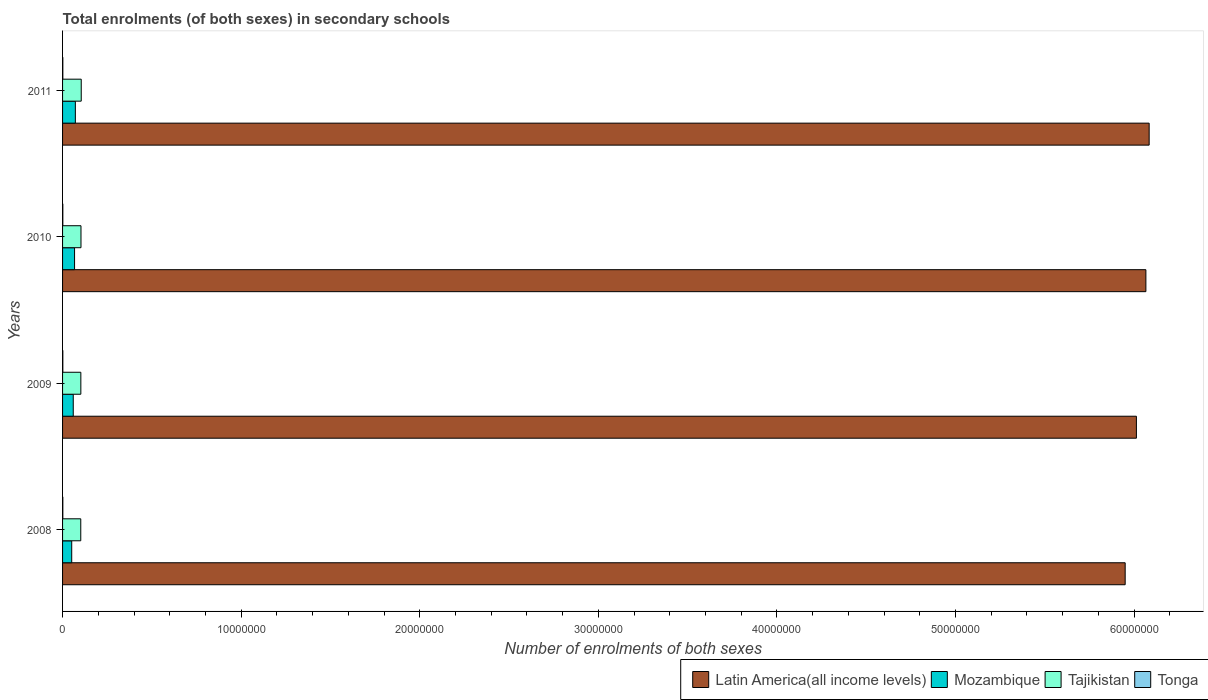How many different coloured bars are there?
Offer a very short reply. 4. How many groups of bars are there?
Ensure brevity in your answer.  4. Are the number of bars per tick equal to the number of legend labels?
Your answer should be compact. Yes. Are the number of bars on each tick of the Y-axis equal?
Your answer should be very brief. Yes. How many bars are there on the 4th tick from the top?
Provide a short and direct response. 4. How many bars are there on the 1st tick from the bottom?
Keep it short and to the point. 4. What is the number of enrolments in secondary schools in Tonga in 2008?
Your response must be concise. 1.46e+04. Across all years, what is the maximum number of enrolments in secondary schools in Tajikistan?
Provide a succinct answer. 1.05e+06. Across all years, what is the minimum number of enrolments in secondary schools in Latin America(all income levels)?
Make the answer very short. 5.95e+07. In which year was the number of enrolments in secondary schools in Latin America(all income levels) maximum?
Make the answer very short. 2011. What is the total number of enrolments in secondary schools in Tajikistan in the graph?
Keep it short and to the point. 4.12e+06. What is the difference between the number of enrolments in secondary schools in Latin America(all income levels) in 2008 and that in 2011?
Keep it short and to the point. -1.34e+06. What is the difference between the number of enrolments in secondary schools in Tonga in 2010 and the number of enrolments in secondary schools in Tajikistan in 2011?
Make the answer very short. -1.03e+06. What is the average number of enrolments in secondary schools in Tonga per year?
Provide a short and direct response. 1.47e+04. In the year 2008, what is the difference between the number of enrolments in secondary schools in Latin America(all income levels) and number of enrolments in secondary schools in Tonga?
Provide a short and direct response. 5.95e+07. What is the ratio of the number of enrolments in secondary schools in Mozambique in 2010 to that in 2011?
Offer a very short reply. 0.94. Is the number of enrolments in secondary schools in Latin America(all income levels) in 2008 less than that in 2011?
Keep it short and to the point. Yes. Is the difference between the number of enrolments in secondary schools in Latin America(all income levels) in 2008 and 2009 greater than the difference between the number of enrolments in secondary schools in Tonga in 2008 and 2009?
Provide a succinct answer. No. What is the difference between the highest and the second highest number of enrolments in secondary schools in Tonga?
Provide a succinct answer. 97. What is the difference between the highest and the lowest number of enrolments in secondary schools in Tonga?
Your response must be concise. 242. In how many years, is the number of enrolments in secondary schools in Tajikistan greater than the average number of enrolments in secondary schools in Tajikistan taken over all years?
Your response must be concise. 2. Is the sum of the number of enrolments in secondary schools in Tonga in 2009 and 2011 greater than the maximum number of enrolments in secondary schools in Mozambique across all years?
Your answer should be compact. No. Is it the case that in every year, the sum of the number of enrolments in secondary schools in Latin America(all income levels) and number of enrolments in secondary schools in Tonga is greater than the sum of number of enrolments in secondary schools in Mozambique and number of enrolments in secondary schools in Tajikistan?
Your answer should be very brief. Yes. What does the 1st bar from the top in 2008 represents?
Keep it short and to the point. Tonga. What does the 1st bar from the bottom in 2009 represents?
Make the answer very short. Latin America(all income levels). How many years are there in the graph?
Offer a very short reply. 4. What is the difference between two consecutive major ticks on the X-axis?
Provide a short and direct response. 1.00e+07. Does the graph contain any zero values?
Keep it short and to the point. No. How are the legend labels stacked?
Provide a short and direct response. Horizontal. What is the title of the graph?
Your answer should be very brief. Total enrolments (of both sexes) in secondary schools. Does "Other small states" appear as one of the legend labels in the graph?
Provide a short and direct response. No. What is the label or title of the X-axis?
Give a very brief answer. Number of enrolments of both sexes. What is the label or title of the Y-axis?
Give a very brief answer. Years. What is the Number of enrolments of both sexes in Latin America(all income levels) in 2008?
Your response must be concise. 5.95e+07. What is the Number of enrolments of both sexes in Mozambique in 2008?
Give a very brief answer. 5.12e+05. What is the Number of enrolments of both sexes in Tajikistan in 2008?
Provide a succinct answer. 1.02e+06. What is the Number of enrolments of both sexes of Tonga in 2008?
Provide a succinct answer. 1.46e+04. What is the Number of enrolments of both sexes of Latin America(all income levels) in 2009?
Your answer should be compact. 6.01e+07. What is the Number of enrolments of both sexes of Mozambique in 2009?
Make the answer very short. 5.98e+05. What is the Number of enrolments of both sexes of Tajikistan in 2009?
Provide a succinct answer. 1.02e+06. What is the Number of enrolments of both sexes in Tonga in 2009?
Offer a terse response. 1.47e+04. What is the Number of enrolments of both sexes in Latin America(all income levels) in 2010?
Offer a very short reply. 6.07e+07. What is the Number of enrolments of both sexes in Mozambique in 2010?
Your answer should be compact. 6.72e+05. What is the Number of enrolments of both sexes of Tajikistan in 2010?
Your answer should be very brief. 1.03e+06. What is the Number of enrolments of both sexes in Tonga in 2010?
Your answer should be very brief. 1.48e+04. What is the Number of enrolments of both sexes in Latin America(all income levels) in 2011?
Your response must be concise. 6.08e+07. What is the Number of enrolments of both sexes of Mozambique in 2011?
Your response must be concise. 7.16e+05. What is the Number of enrolments of both sexes in Tajikistan in 2011?
Your answer should be very brief. 1.05e+06. What is the Number of enrolments of both sexes in Tonga in 2011?
Your answer should be compact. 1.49e+04. Across all years, what is the maximum Number of enrolments of both sexes in Latin America(all income levels)?
Keep it short and to the point. 6.08e+07. Across all years, what is the maximum Number of enrolments of both sexes in Mozambique?
Keep it short and to the point. 7.16e+05. Across all years, what is the maximum Number of enrolments of both sexes in Tajikistan?
Your answer should be very brief. 1.05e+06. Across all years, what is the maximum Number of enrolments of both sexes of Tonga?
Your response must be concise. 1.49e+04. Across all years, what is the minimum Number of enrolments of both sexes in Latin America(all income levels)?
Provide a succinct answer. 5.95e+07. Across all years, what is the minimum Number of enrolments of both sexes in Mozambique?
Make the answer very short. 5.12e+05. Across all years, what is the minimum Number of enrolments of both sexes of Tajikistan?
Provide a short and direct response. 1.02e+06. Across all years, what is the minimum Number of enrolments of both sexes of Tonga?
Make the answer very short. 1.46e+04. What is the total Number of enrolments of both sexes of Latin America(all income levels) in the graph?
Your answer should be compact. 2.41e+08. What is the total Number of enrolments of both sexes of Mozambique in the graph?
Your answer should be very brief. 2.50e+06. What is the total Number of enrolments of both sexes of Tajikistan in the graph?
Offer a terse response. 4.12e+06. What is the total Number of enrolments of both sexes of Tonga in the graph?
Your response must be concise. 5.90e+04. What is the difference between the Number of enrolments of both sexes in Latin America(all income levels) in 2008 and that in 2009?
Keep it short and to the point. -6.29e+05. What is the difference between the Number of enrolments of both sexes in Mozambique in 2008 and that in 2009?
Your answer should be compact. -8.62e+04. What is the difference between the Number of enrolments of both sexes in Tajikistan in 2008 and that in 2009?
Provide a succinct answer. -4121. What is the difference between the Number of enrolments of both sexes in Tonga in 2008 and that in 2009?
Ensure brevity in your answer.  -44. What is the difference between the Number of enrolments of both sexes in Latin America(all income levels) in 2008 and that in 2010?
Make the answer very short. -1.16e+06. What is the difference between the Number of enrolments of both sexes of Mozambique in 2008 and that in 2010?
Your answer should be compact. -1.60e+05. What is the difference between the Number of enrolments of both sexes in Tajikistan in 2008 and that in 2010?
Make the answer very short. -1.25e+04. What is the difference between the Number of enrolments of both sexes in Tonga in 2008 and that in 2010?
Provide a succinct answer. -145. What is the difference between the Number of enrolments of both sexes in Latin America(all income levels) in 2008 and that in 2011?
Provide a succinct answer. -1.34e+06. What is the difference between the Number of enrolments of both sexes of Mozambique in 2008 and that in 2011?
Provide a succinct answer. -2.04e+05. What is the difference between the Number of enrolments of both sexes in Tajikistan in 2008 and that in 2011?
Your answer should be very brief. -2.59e+04. What is the difference between the Number of enrolments of both sexes of Tonga in 2008 and that in 2011?
Make the answer very short. -242. What is the difference between the Number of enrolments of both sexes in Latin America(all income levels) in 2009 and that in 2010?
Give a very brief answer. -5.31e+05. What is the difference between the Number of enrolments of both sexes of Mozambique in 2009 and that in 2010?
Give a very brief answer. -7.35e+04. What is the difference between the Number of enrolments of both sexes in Tajikistan in 2009 and that in 2010?
Give a very brief answer. -8352. What is the difference between the Number of enrolments of both sexes of Tonga in 2009 and that in 2010?
Ensure brevity in your answer.  -101. What is the difference between the Number of enrolments of both sexes in Latin America(all income levels) in 2009 and that in 2011?
Make the answer very short. -7.14e+05. What is the difference between the Number of enrolments of both sexes in Mozambique in 2009 and that in 2011?
Provide a short and direct response. -1.18e+05. What is the difference between the Number of enrolments of both sexes of Tajikistan in 2009 and that in 2011?
Ensure brevity in your answer.  -2.18e+04. What is the difference between the Number of enrolments of both sexes in Tonga in 2009 and that in 2011?
Your answer should be compact. -198. What is the difference between the Number of enrolments of both sexes in Latin America(all income levels) in 2010 and that in 2011?
Make the answer very short. -1.84e+05. What is the difference between the Number of enrolments of both sexes in Mozambique in 2010 and that in 2011?
Your answer should be compact. -4.44e+04. What is the difference between the Number of enrolments of both sexes of Tajikistan in 2010 and that in 2011?
Provide a succinct answer. -1.35e+04. What is the difference between the Number of enrolments of both sexes in Tonga in 2010 and that in 2011?
Your response must be concise. -97. What is the difference between the Number of enrolments of both sexes of Latin America(all income levels) in 2008 and the Number of enrolments of both sexes of Mozambique in 2009?
Keep it short and to the point. 5.89e+07. What is the difference between the Number of enrolments of both sexes in Latin America(all income levels) in 2008 and the Number of enrolments of both sexes in Tajikistan in 2009?
Provide a succinct answer. 5.85e+07. What is the difference between the Number of enrolments of both sexes of Latin America(all income levels) in 2008 and the Number of enrolments of both sexes of Tonga in 2009?
Your answer should be very brief. 5.95e+07. What is the difference between the Number of enrolments of both sexes in Mozambique in 2008 and the Number of enrolments of both sexes in Tajikistan in 2009?
Give a very brief answer. -5.11e+05. What is the difference between the Number of enrolments of both sexes in Mozambique in 2008 and the Number of enrolments of both sexes in Tonga in 2009?
Your response must be concise. 4.98e+05. What is the difference between the Number of enrolments of both sexes of Tajikistan in 2008 and the Number of enrolments of both sexes of Tonga in 2009?
Provide a short and direct response. 1.00e+06. What is the difference between the Number of enrolments of both sexes in Latin America(all income levels) in 2008 and the Number of enrolments of both sexes in Mozambique in 2010?
Offer a very short reply. 5.88e+07. What is the difference between the Number of enrolments of both sexes in Latin America(all income levels) in 2008 and the Number of enrolments of both sexes in Tajikistan in 2010?
Offer a terse response. 5.85e+07. What is the difference between the Number of enrolments of both sexes in Latin America(all income levels) in 2008 and the Number of enrolments of both sexes in Tonga in 2010?
Offer a terse response. 5.95e+07. What is the difference between the Number of enrolments of both sexes of Mozambique in 2008 and the Number of enrolments of both sexes of Tajikistan in 2010?
Give a very brief answer. -5.19e+05. What is the difference between the Number of enrolments of both sexes of Mozambique in 2008 and the Number of enrolments of both sexes of Tonga in 2010?
Provide a short and direct response. 4.97e+05. What is the difference between the Number of enrolments of both sexes of Tajikistan in 2008 and the Number of enrolments of both sexes of Tonga in 2010?
Your answer should be compact. 1.00e+06. What is the difference between the Number of enrolments of both sexes in Latin America(all income levels) in 2008 and the Number of enrolments of both sexes in Mozambique in 2011?
Make the answer very short. 5.88e+07. What is the difference between the Number of enrolments of both sexes in Latin America(all income levels) in 2008 and the Number of enrolments of both sexes in Tajikistan in 2011?
Your answer should be very brief. 5.85e+07. What is the difference between the Number of enrolments of both sexes of Latin America(all income levels) in 2008 and the Number of enrolments of both sexes of Tonga in 2011?
Your response must be concise. 5.95e+07. What is the difference between the Number of enrolments of both sexes of Mozambique in 2008 and the Number of enrolments of both sexes of Tajikistan in 2011?
Offer a terse response. -5.33e+05. What is the difference between the Number of enrolments of both sexes in Mozambique in 2008 and the Number of enrolments of both sexes in Tonga in 2011?
Give a very brief answer. 4.97e+05. What is the difference between the Number of enrolments of both sexes in Tajikistan in 2008 and the Number of enrolments of both sexes in Tonga in 2011?
Keep it short and to the point. 1.00e+06. What is the difference between the Number of enrolments of both sexes of Latin America(all income levels) in 2009 and the Number of enrolments of both sexes of Mozambique in 2010?
Provide a short and direct response. 5.95e+07. What is the difference between the Number of enrolments of both sexes in Latin America(all income levels) in 2009 and the Number of enrolments of both sexes in Tajikistan in 2010?
Provide a short and direct response. 5.91e+07. What is the difference between the Number of enrolments of both sexes in Latin America(all income levels) in 2009 and the Number of enrolments of both sexes in Tonga in 2010?
Make the answer very short. 6.01e+07. What is the difference between the Number of enrolments of both sexes in Mozambique in 2009 and the Number of enrolments of both sexes in Tajikistan in 2010?
Keep it short and to the point. -4.33e+05. What is the difference between the Number of enrolments of both sexes of Mozambique in 2009 and the Number of enrolments of both sexes of Tonga in 2010?
Give a very brief answer. 5.84e+05. What is the difference between the Number of enrolments of both sexes in Tajikistan in 2009 and the Number of enrolments of both sexes in Tonga in 2010?
Your response must be concise. 1.01e+06. What is the difference between the Number of enrolments of both sexes of Latin America(all income levels) in 2009 and the Number of enrolments of both sexes of Mozambique in 2011?
Make the answer very short. 5.94e+07. What is the difference between the Number of enrolments of both sexes in Latin America(all income levels) in 2009 and the Number of enrolments of both sexes in Tajikistan in 2011?
Give a very brief answer. 5.91e+07. What is the difference between the Number of enrolments of both sexes of Latin America(all income levels) in 2009 and the Number of enrolments of both sexes of Tonga in 2011?
Offer a very short reply. 6.01e+07. What is the difference between the Number of enrolments of both sexes in Mozambique in 2009 and the Number of enrolments of both sexes in Tajikistan in 2011?
Give a very brief answer. -4.47e+05. What is the difference between the Number of enrolments of both sexes in Mozambique in 2009 and the Number of enrolments of both sexes in Tonga in 2011?
Your answer should be compact. 5.84e+05. What is the difference between the Number of enrolments of both sexes of Tajikistan in 2009 and the Number of enrolments of both sexes of Tonga in 2011?
Your answer should be very brief. 1.01e+06. What is the difference between the Number of enrolments of both sexes of Latin America(all income levels) in 2010 and the Number of enrolments of both sexes of Mozambique in 2011?
Offer a very short reply. 5.99e+07. What is the difference between the Number of enrolments of both sexes of Latin America(all income levels) in 2010 and the Number of enrolments of both sexes of Tajikistan in 2011?
Provide a succinct answer. 5.96e+07. What is the difference between the Number of enrolments of both sexes in Latin America(all income levels) in 2010 and the Number of enrolments of both sexes in Tonga in 2011?
Ensure brevity in your answer.  6.06e+07. What is the difference between the Number of enrolments of both sexes in Mozambique in 2010 and the Number of enrolments of both sexes in Tajikistan in 2011?
Ensure brevity in your answer.  -3.73e+05. What is the difference between the Number of enrolments of both sexes of Mozambique in 2010 and the Number of enrolments of both sexes of Tonga in 2011?
Ensure brevity in your answer.  6.57e+05. What is the difference between the Number of enrolments of both sexes in Tajikistan in 2010 and the Number of enrolments of both sexes in Tonga in 2011?
Your response must be concise. 1.02e+06. What is the average Number of enrolments of both sexes in Latin America(all income levels) per year?
Provide a succinct answer. 6.03e+07. What is the average Number of enrolments of both sexes in Mozambique per year?
Provide a succinct answer. 6.25e+05. What is the average Number of enrolments of both sexes of Tajikistan per year?
Your answer should be very brief. 1.03e+06. What is the average Number of enrolments of both sexes in Tonga per year?
Your response must be concise. 1.47e+04. In the year 2008, what is the difference between the Number of enrolments of both sexes in Latin America(all income levels) and Number of enrolments of both sexes in Mozambique?
Your answer should be compact. 5.90e+07. In the year 2008, what is the difference between the Number of enrolments of both sexes of Latin America(all income levels) and Number of enrolments of both sexes of Tajikistan?
Ensure brevity in your answer.  5.85e+07. In the year 2008, what is the difference between the Number of enrolments of both sexes of Latin America(all income levels) and Number of enrolments of both sexes of Tonga?
Ensure brevity in your answer.  5.95e+07. In the year 2008, what is the difference between the Number of enrolments of both sexes in Mozambique and Number of enrolments of both sexes in Tajikistan?
Provide a succinct answer. -5.07e+05. In the year 2008, what is the difference between the Number of enrolments of both sexes in Mozambique and Number of enrolments of both sexes in Tonga?
Your response must be concise. 4.98e+05. In the year 2008, what is the difference between the Number of enrolments of both sexes of Tajikistan and Number of enrolments of both sexes of Tonga?
Make the answer very short. 1.00e+06. In the year 2009, what is the difference between the Number of enrolments of both sexes of Latin America(all income levels) and Number of enrolments of both sexes of Mozambique?
Keep it short and to the point. 5.95e+07. In the year 2009, what is the difference between the Number of enrolments of both sexes in Latin America(all income levels) and Number of enrolments of both sexes in Tajikistan?
Ensure brevity in your answer.  5.91e+07. In the year 2009, what is the difference between the Number of enrolments of both sexes of Latin America(all income levels) and Number of enrolments of both sexes of Tonga?
Your answer should be very brief. 6.01e+07. In the year 2009, what is the difference between the Number of enrolments of both sexes in Mozambique and Number of enrolments of both sexes in Tajikistan?
Offer a very short reply. -4.25e+05. In the year 2009, what is the difference between the Number of enrolments of both sexes of Mozambique and Number of enrolments of both sexes of Tonga?
Your answer should be very brief. 5.84e+05. In the year 2009, what is the difference between the Number of enrolments of both sexes in Tajikistan and Number of enrolments of both sexes in Tonga?
Give a very brief answer. 1.01e+06. In the year 2010, what is the difference between the Number of enrolments of both sexes in Latin America(all income levels) and Number of enrolments of both sexes in Mozambique?
Offer a very short reply. 6.00e+07. In the year 2010, what is the difference between the Number of enrolments of both sexes of Latin America(all income levels) and Number of enrolments of both sexes of Tajikistan?
Ensure brevity in your answer.  5.96e+07. In the year 2010, what is the difference between the Number of enrolments of both sexes of Latin America(all income levels) and Number of enrolments of both sexes of Tonga?
Ensure brevity in your answer.  6.06e+07. In the year 2010, what is the difference between the Number of enrolments of both sexes of Mozambique and Number of enrolments of both sexes of Tajikistan?
Your answer should be compact. -3.60e+05. In the year 2010, what is the difference between the Number of enrolments of both sexes of Mozambique and Number of enrolments of both sexes of Tonga?
Provide a succinct answer. 6.57e+05. In the year 2010, what is the difference between the Number of enrolments of both sexes in Tajikistan and Number of enrolments of both sexes in Tonga?
Offer a terse response. 1.02e+06. In the year 2011, what is the difference between the Number of enrolments of both sexes of Latin America(all income levels) and Number of enrolments of both sexes of Mozambique?
Make the answer very short. 6.01e+07. In the year 2011, what is the difference between the Number of enrolments of both sexes of Latin America(all income levels) and Number of enrolments of both sexes of Tajikistan?
Provide a succinct answer. 5.98e+07. In the year 2011, what is the difference between the Number of enrolments of both sexes of Latin America(all income levels) and Number of enrolments of both sexes of Tonga?
Provide a succinct answer. 6.08e+07. In the year 2011, what is the difference between the Number of enrolments of both sexes of Mozambique and Number of enrolments of both sexes of Tajikistan?
Your response must be concise. -3.29e+05. In the year 2011, what is the difference between the Number of enrolments of both sexes in Mozambique and Number of enrolments of both sexes in Tonga?
Your answer should be compact. 7.01e+05. In the year 2011, what is the difference between the Number of enrolments of both sexes of Tajikistan and Number of enrolments of both sexes of Tonga?
Offer a terse response. 1.03e+06. What is the ratio of the Number of enrolments of both sexes of Latin America(all income levels) in 2008 to that in 2009?
Ensure brevity in your answer.  0.99. What is the ratio of the Number of enrolments of both sexes in Mozambique in 2008 to that in 2009?
Offer a terse response. 0.86. What is the ratio of the Number of enrolments of both sexes of Latin America(all income levels) in 2008 to that in 2010?
Offer a very short reply. 0.98. What is the ratio of the Number of enrolments of both sexes of Mozambique in 2008 to that in 2010?
Ensure brevity in your answer.  0.76. What is the ratio of the Number of enrolments of both sexes of Tajikistan in 2008 to that in 2010?
Keep it short and to the point. 0.99. What is the ratio of the Number of enrolments of both sexes of Tonga in 2008 to that in 2010?
Offer a terse response. 0.99. What is the ratio of the Number of enrolments of both sexes in Latin America(all income levels) in 2008 to that in 2011?
Your response must be concise. 0.98. What is the ratio of the Number of enrolments of both sexes in Mozambique in 2008 to that in 2011?
Make the answer very short. 0.72. What is the ratio of the Number of enrolments of both sexes in Tajikistan in 2008 to that in 2011?
Offer a terse response. 0.98. What is the ratio of the Number of enrolments of both sexes of Tonga in 2008 to that in 2011?
Provide a succinct answer. 0.98. What is the ratio of the Number of enrolments of both sexes of Mozambique in 2009 to that in 2010?
Your answer should be very brief. 0.89. What is the ratio of the Number of enrolments of both sexes of Latin America(all income levels) in 2009 to that in 2011?
Offer a very short reply. 0.99. What is the ratio of the Number of enrolments of both sexes of Mozambique in 2009 to that in 2011?
Your response must be concise. 0.84. What is the ratio of the Number of enrolments of both sexes of Tajikistan in 2009 to that in 2011?
Your answer should be very brief. 0.98. What is the ratio of the Number of enrolments of both sexes in Tonga in 2009 to that in 2011?
Give a very brief answer. 0.99. What is the ratio of the Number of enrolments of both sexes of Latin America(all income levels) in 2010 to that in 2011?
Your response must be concise. 1. What is the ratio of the Number of enrolments of both sexes of Mozambique in 2010 to that in 2011?
Offer a terse response. 0.94. What is the ratio of the Number of enrolments of both sexes of Tajikistan in 2010 to that in 2011?
Provide a succinct answer. 0.99. What is the difference between the highest and the second highest Number of enrolments of both sexes in Latin America(all income levels)?
Your answer should be compact. 1.84e+05. What is the difference between the highest and the second highest Number of enrolments of both sexes in Mozambique?
Make the answer very short. 4.44e+04. What is the difference between the highest and the second highest Number of enrolments of both sexes of Tajikistan?
Provide a short and direct response. 1.35e+04. What is the difference between the highest and the second highest Number of enrolments of both sexes of Tonga?
Offer a very short reply. 97. What is the difference between the highest and the lowest Number of enrolments of both sexes in Latin America(all income levels)?
Make the answer very short. 1.34e+06. What is the difference between the highest and the lowest Number of enrolments of both sexes in Mozambique?
Provide a short and direct response. 2.04e+05. What is the difference between the highest and the lowest Number of enrolments of both sexes in Tajikistan?
Your answer should be compact. 2.59e+04. What is the difference between the highest and the lowest Number of enrolments of both sexes in Tonga?
Provide a short and direct response. 242. 